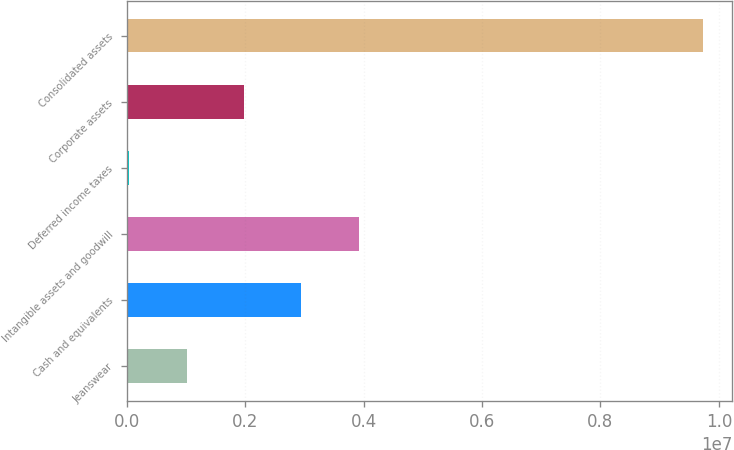Convert chart. <chart><loc_0><loc_0><loc_500><loc_500><bar_chart><fcel>Jeanswear<fcel>Cash and equivalents<fcel>Intangible assets and goodwill<fcel>Deferred income taxes<fcel>Corporate assets<fcel>Consolidated assets<nl><fcel>1.01194e+06<fcel>2.95135e+06<fcel>3.92105e+06<fcel>42231<fcel>1.98164e+06<fcel>9.73929e+06<nl></chart> 